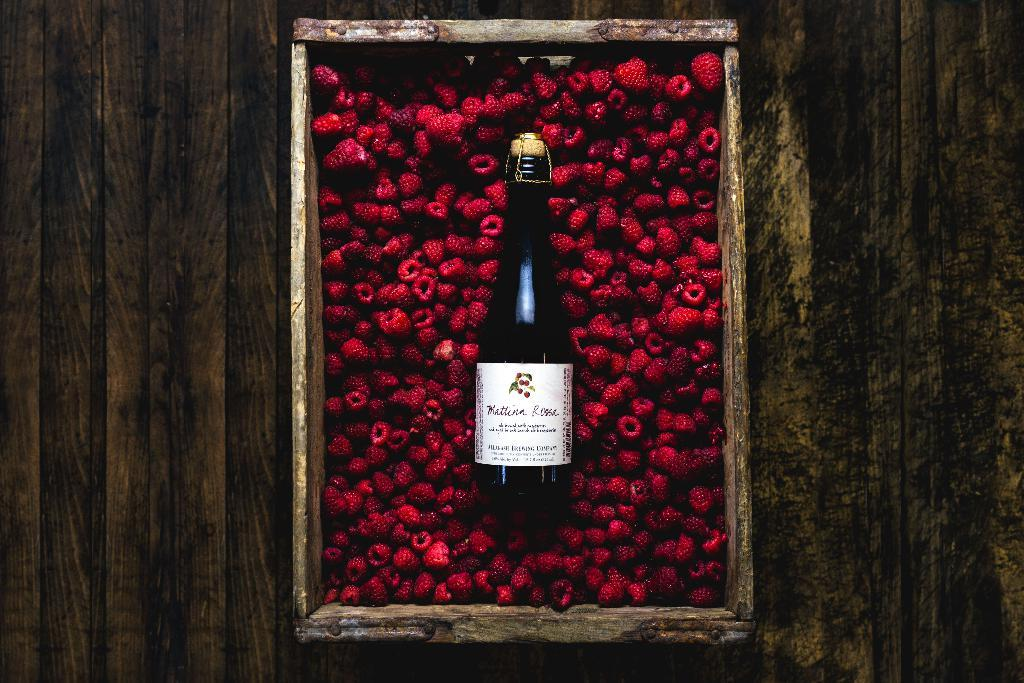<image>
Present a compact description of the photo's key features. A bottle of Mattina Rossa in a container of red raspberries. 